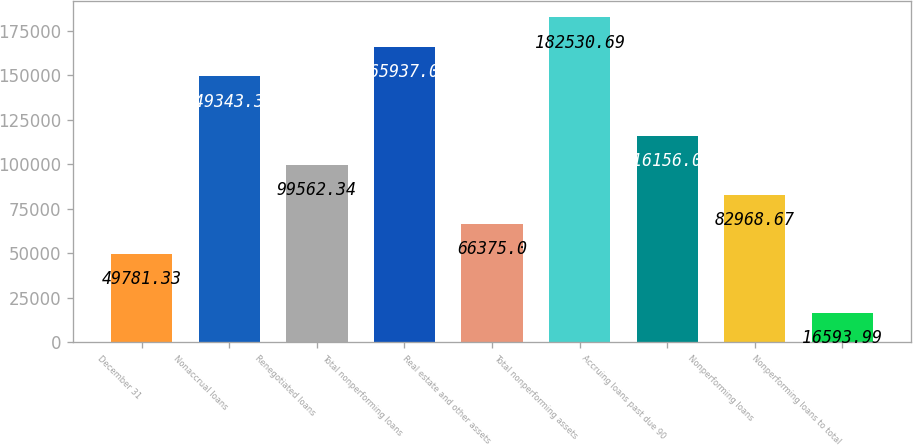Convert chart. <chart><loc_0><loc_0><loc_500><loc_500><bar_chart><fcel>December 31<fcel>Nonaccrual loans<fcel>Renegotiated loans<fcel>Total nonperforming loans<fcel>Real estate and other assets<fcel>Total nonperforming assets<fcel>Accruing loans past due 90<fcel>Nonperforming loans<fcel>Nonperforming loans to total<nl><fcel>49781.3<fcel>149343<fcel>99562.3<fcel>165937<fcel>66375<fcel>182531<fcel>116156<fcel>82968.7<fcel>16594<nl></chart> 